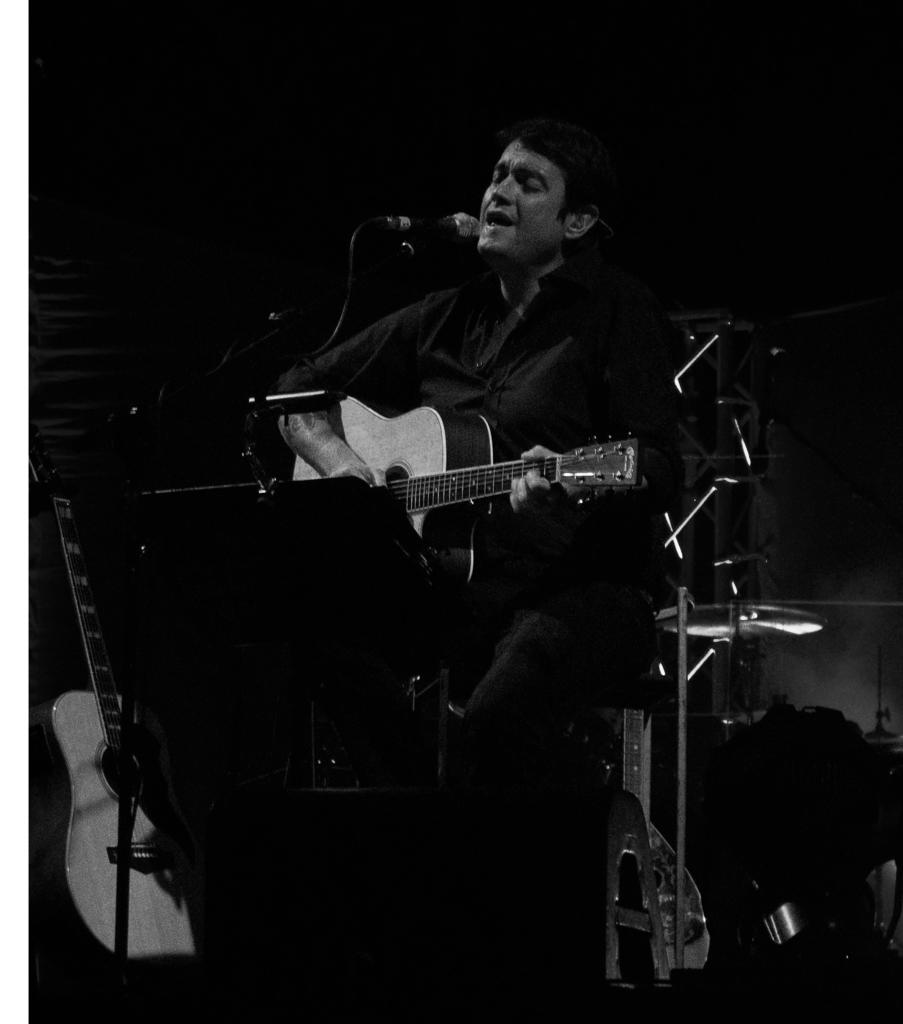What is the main subject of the image? The main subject of the image is a man. What is the man doing in the image? The man is standing in the image. What object is the man holding? The man is holding a guitar in the image. What other musical equipment can be seen in the image? There is a microphone and a microphone stand in the image. Are there any additional guitars visible in the image? Yes, there is another guitar in the image. What type of feather is the man using to play the guitar in the image? There is no feather present in the image, and the man is not using a feather to play the guitar. How many roses can be seen in the image? There are no roses present in the image. 